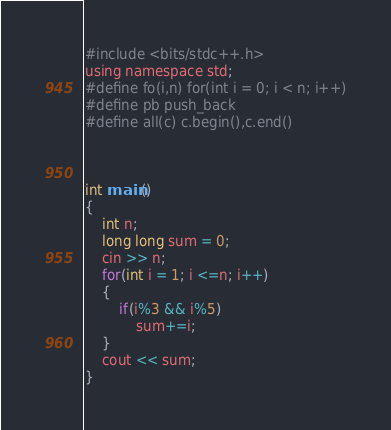Convert code to text. <code><loc_0><loc_0><loc_500><loc_500><_C_>#include <bits/stdc++.h>
using namespace std;
#define fo(i,n) for(int i = 0; i < n; i++)
#define pb push_back
#define all(c) c.begin(),c.end()



int main()
{
    int n;
    long long sum = 0;
    cin >> n;
    for(int i = 1; i <=n; i++)
    {
        if(i%3 && i%5)
            sum+=i;
    }
    cout << sum;
}
</code> 